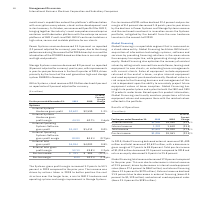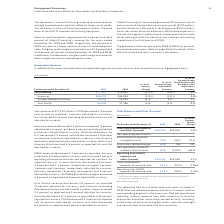According to International Business Machines's financial document, What caused the Global Financing total revenue to decrease? This was due to a decrease in internal revenue of 23.5 percent, driven by decreases in internal used equipment sales (down 27.4 percent to $862 million) and internal financing (down 12.6 percent to $370 million).. The document states: "decreased 17.8 percent compared to the prior year. This was due to a decrease in internal revenue of 23.5 percent, driven by decreases in internal use..." Also, What caused the internal financing revenue to decrease? The decrease in internal financing revenue was due to lower average asset balances, partially offset by higher asset yields. The decrease in external financing revenue reflects the wind down of the OEM IT commercial financing operations.. The document states: "The decrease in internal financing revenue was due to lower average asset balances, partially offset by higher asset yields. The decrease in external ..." Also, What caused the sales of used equipment to decrease? The decrease in 2019 was due to a lower volume of internal used equipment sales.. The document states: "rs ended December 31, 2019 and 2018, respectively. The decrease in 2019 was due to a lower volume of internal used equipment sales. The gross profit m..." Also, can you calculate: What is the average External revenue? To answer this question, I need to perform calculations using the financial data. The calculation is: (1,400 + 1,590) / 2, which equals 1495 (in millions). This is based on the information: "External revenue $1,400 $1,590 (11.9 )% External revenue $1,400 $1,590 (11.9 )%..." The key data points involved are: 1,400, 1,590. Also, can you calculate: What is the increase / (decrease) in the internal revenue from 2018 to 2019? Based on the calculation: 1,232 - 1,610, the result is -378 (in millions). This is based on the information: "Internal revenue 1,232 1,610 (23.5) Internal revenue 1,232 1,610 (23.5)..." The key data points involved are: 1,232, 1,610. Also, can you calculate: What percentage of total revenue is Pre-tax income in 2019? Based on the calculation: 1,055 / 2,632, the result is 40.08 (percentage). This is based on the information: "Total revenue $2,632 $3,200 (17.8 )% Pre-tax income $1,055 $1,361 (22.5)%..." The key data points involved are: 1,055, 2,632. 